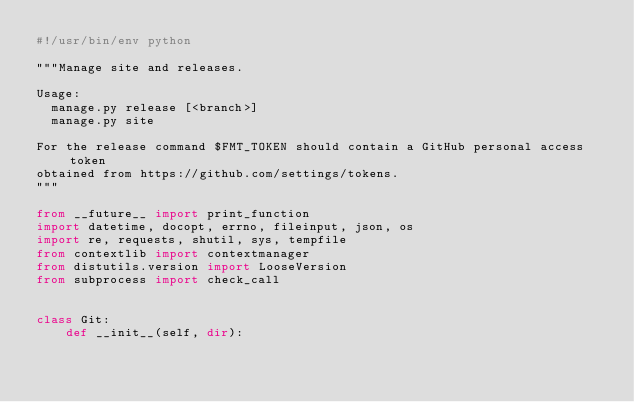<code> <loc_0><loc_0><loc_500><loc_500><_Python_>#!/usr/bin/env python

"""Manage site and releases.

Usage:
  manage.py release [<branch>]
  manage.py site

For the release command $FMT_TOKEN should contain a GitHub personal access token
obtained from https://github.com/settings/tokens.
"""

from __future__ import print_function
import datetime, docopt, errno, fileinput, json, os
import re, requests, shutil, sys, tempfile
from contextlib import contextmanager
from distutils.version import LooseVersion
from subprocess import check_call


class Git:
    def __init__(self, dir):</code> 